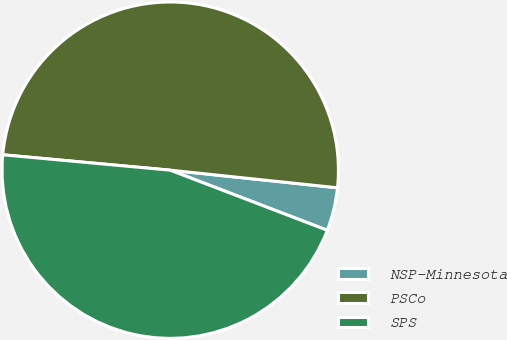Convert chart. <chart><loc_0><loc_0><loc_500><loc_500><pie_chart><fcel>NSP-Minnesota<fcel>PSCo<fcel>SPS<nl><fcel>4.15%<fcel>50.21%<fcel>45.64%<nl></chart> 